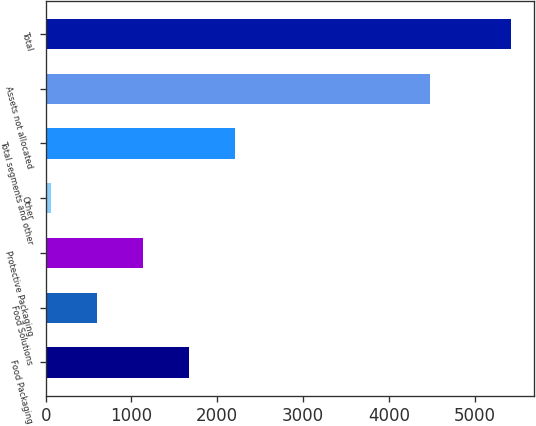<chart> <loc_0><loc_0><loc_500><loc_500><bar_chart><fcel>Food Packaging<fcel>Food Solutions<fcel>Protective Packaging<fcel>Other<fcel>Total segments and other<fcel>Assets not allocated<fcel>Total<nl><fcel>1666.56<fcel>594.12<fcel>1130.34<fcel>57.9<fcel>2202.78<fcel>4484.3<fcel>5420.1<nl></chart> 